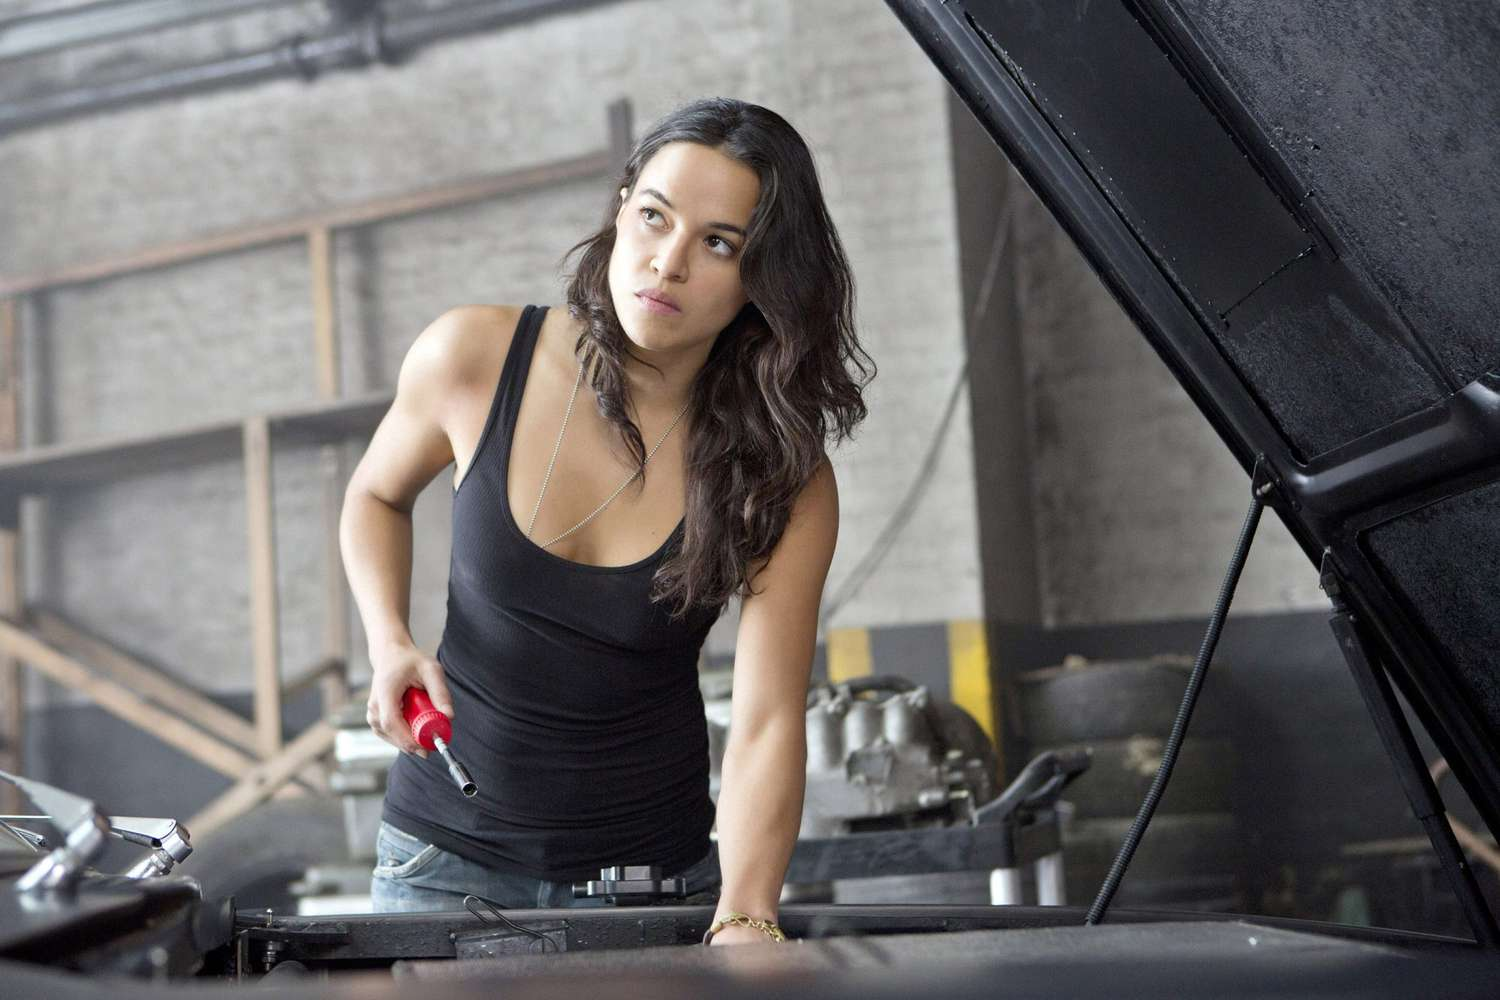Analyze the image in a comprehensive and detailed manner. The image portrays a woman in a garage setting, likely engaged in mechanical work. She stands in front of an open car hood, implying she might be inspecting or fixing the car. Dressed in practical attire of a black tank top and denim jeans, and holding a wrench in her right hand, her outfit and tool choice suggest preparation for mechanical tasks. Her expression and posture indicate concentration and a serious approach to the work at hand. The environment includes elements typical of a garage, like visible tools and car parts, fitting the scene of auto repair or maintenance. 